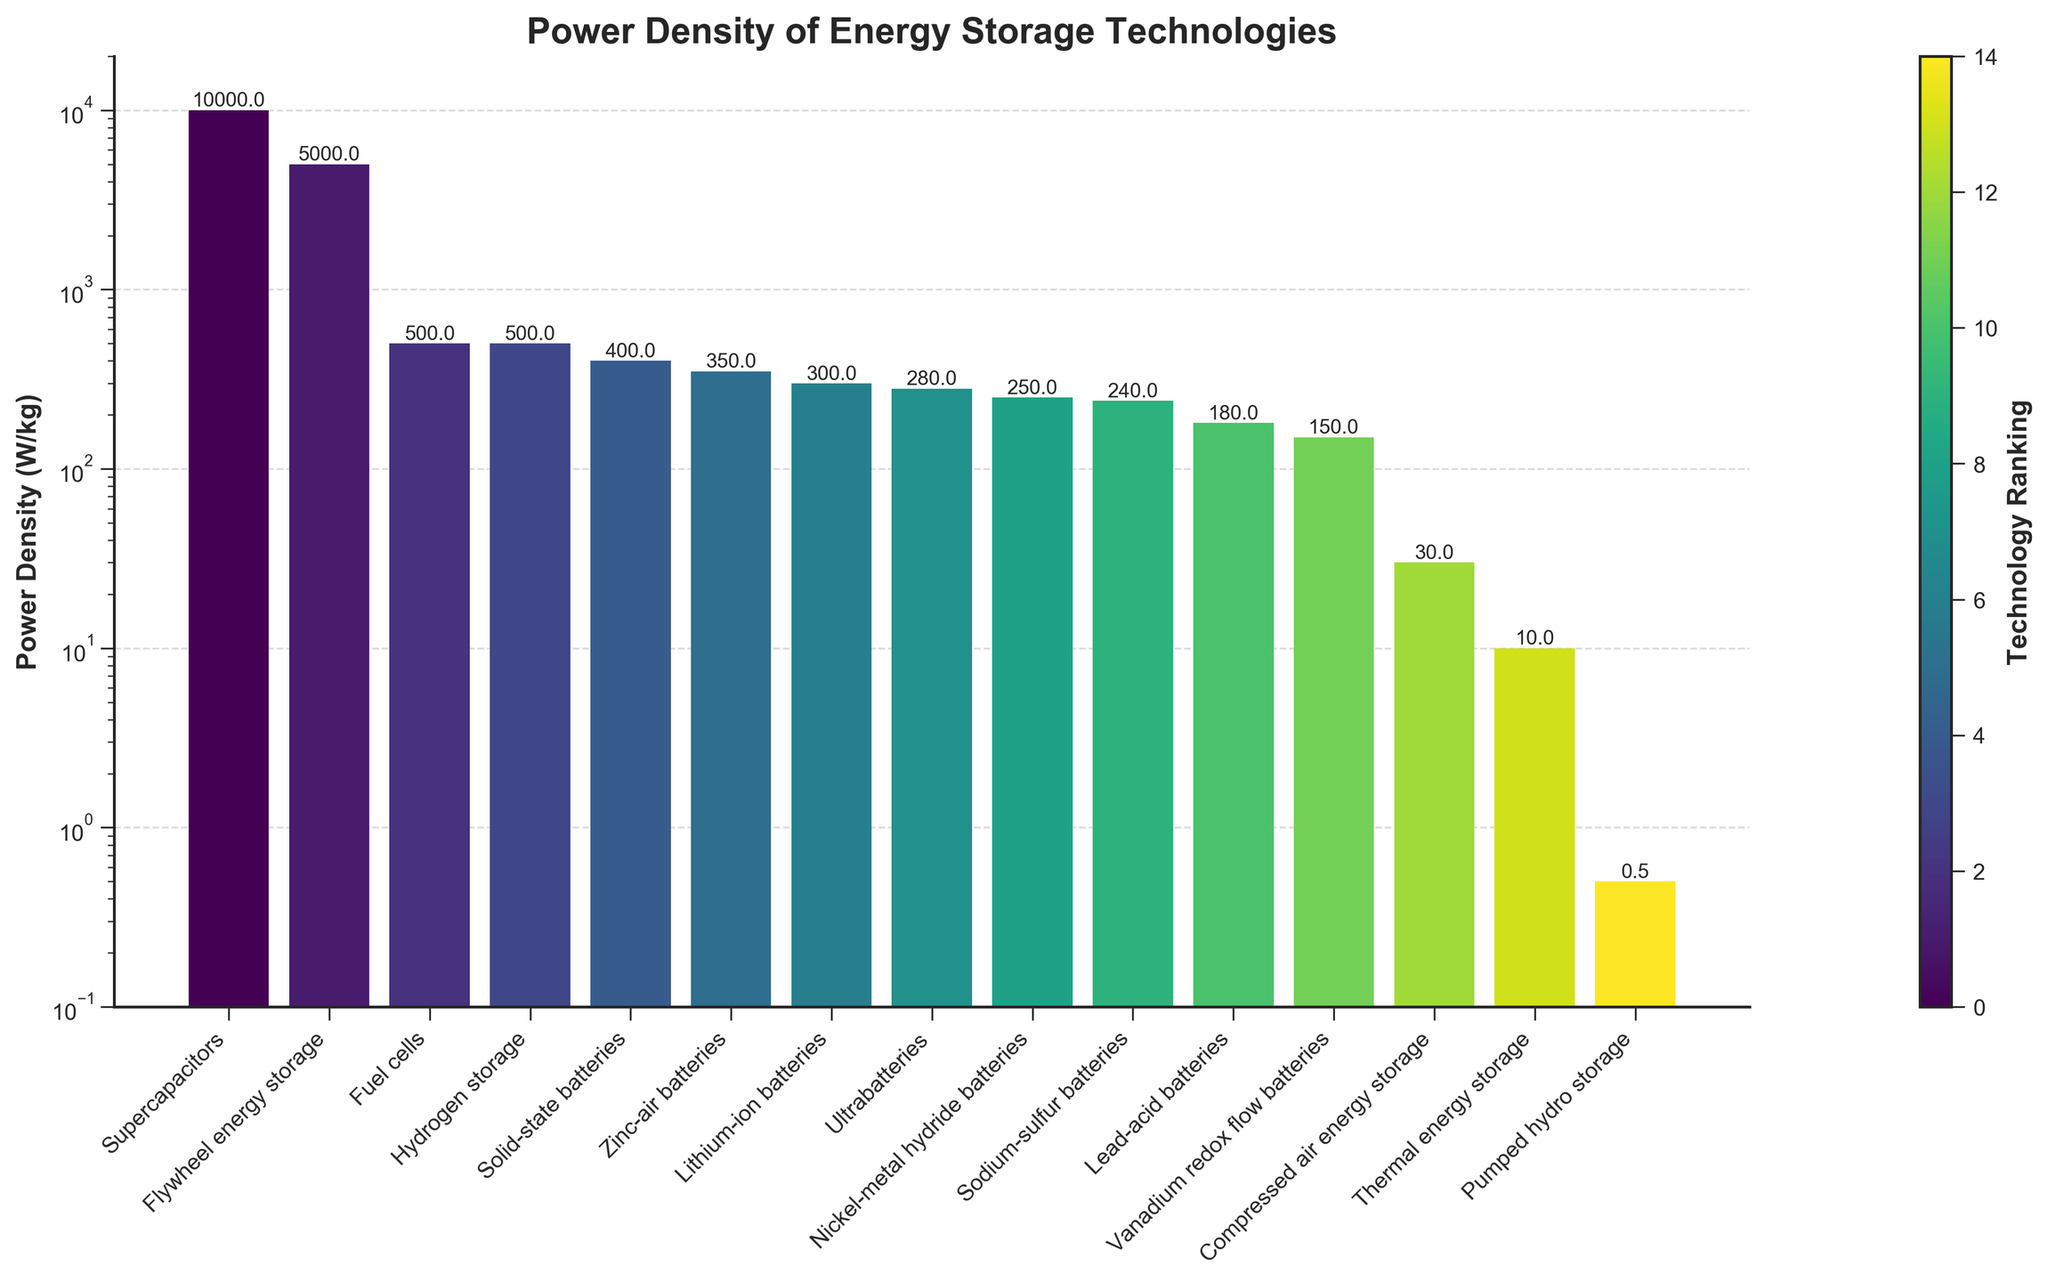Which technology has the highest power density? By examining the bar chart, identify the technology with the tallest bar, which indicates the highest power density. In this case, Supercapacitors have the tallest bar.
Answer: Supercapacitors Which technology has a power density lower than 100 W/kg? Look for bars that do not reach the 100 W/kg mark on the y-axis. The technologies with power densities lower than 100 W/kg are Compressed air energy storage, Pumped hydro storage, and Thermal energy storage.
Answer: Compressed air energy storage, Pumped hydro storage, Thermal energy storage How much higher is the power density of Supercapacitors compared to Lithium-ion batteries? Subtract the power density of Lithium-ion batteries from that of Supercapacitors. The values are 10000 W/kg for Supercapacitors and 300 W/kg for Lithium-ion batteries; thus, the difference is 10000 - 300.
Answer: 9700 W/kg Which two technologies have the closest power densities? Identify two adjacent bars that have the smallest visual difference in height. The closest power densities are for Sodium-sulfur batteries (240 W/kg) and Nickel-metal hydride batteries (250 W/kg), with a difference of 10 W/kg.
Answer: Sodium-sulfur batteries and Nickel-metal hydride batteries What is the median power density of all the technologies listed? List all power densities in ascending order and find the middle value. Since there are 15 technologies, the median is the 8th value when sorted. Sorted values (in W/kg): 0.5, 10, 30, 150, 180, 240, 250, 280, 300, 350, 400, 500, 500, 5000, 10000. The middle value (8th) is 280 W/kg.
Answer: 280 W/kg Which technology has a power density equal to 500 W/kg? Locate the bar that reaches exactly 500 W/kg on the y-axis. In this case, there are two bars at the same height, representing Hydrogen storage and Fuel cells.
Answer: Hydrogen storage, Fuel cells How many technologies have a power density of 300 W/kg or higher? Count the bars that reach or surpass the 300 W/kg mark on the y-axis. These technologies are Lithium-ion batteries, Zinc-air batteries, Solid-state batteries, Ultrabatteries, Fuel cells, Flywheel energy storage, and Supercapacitors, totaling 7 technologies.
Answer: 7 What are the top three technologies in terms of power density? Identify the three tallest bars on the graph. The technologies with the highest power densities are Supercapacitors, Flywheel energy storage, and Hydrogen storage/Fuel cells (tied for third place).
Answer: Supercapacitors, Flywheel energy storage, Hydrogen storage/Fuel cells Which technology ranks fifth in power density? Sort the bars visually in descending order of height and count to the fifth bar. The fifth highest power density belongs to Solid-state batteries with 400 W/kg.
Answer: Solid-state batteries What is the range of power densities in the dataset? Subtract the smallest power density from the largest. The smallest power density is 0.5 W/kg (Pumped hydro storage), and the largest is 10000 W/kg (Supercapacitors); thus, the range is 10000 - 0.5.
Answer: 9999.5 W/kg 